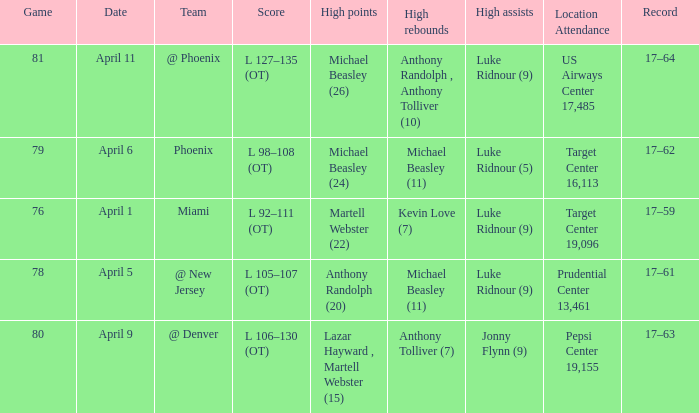How many different results for high rebounds were there for game number 76? 1.0. 